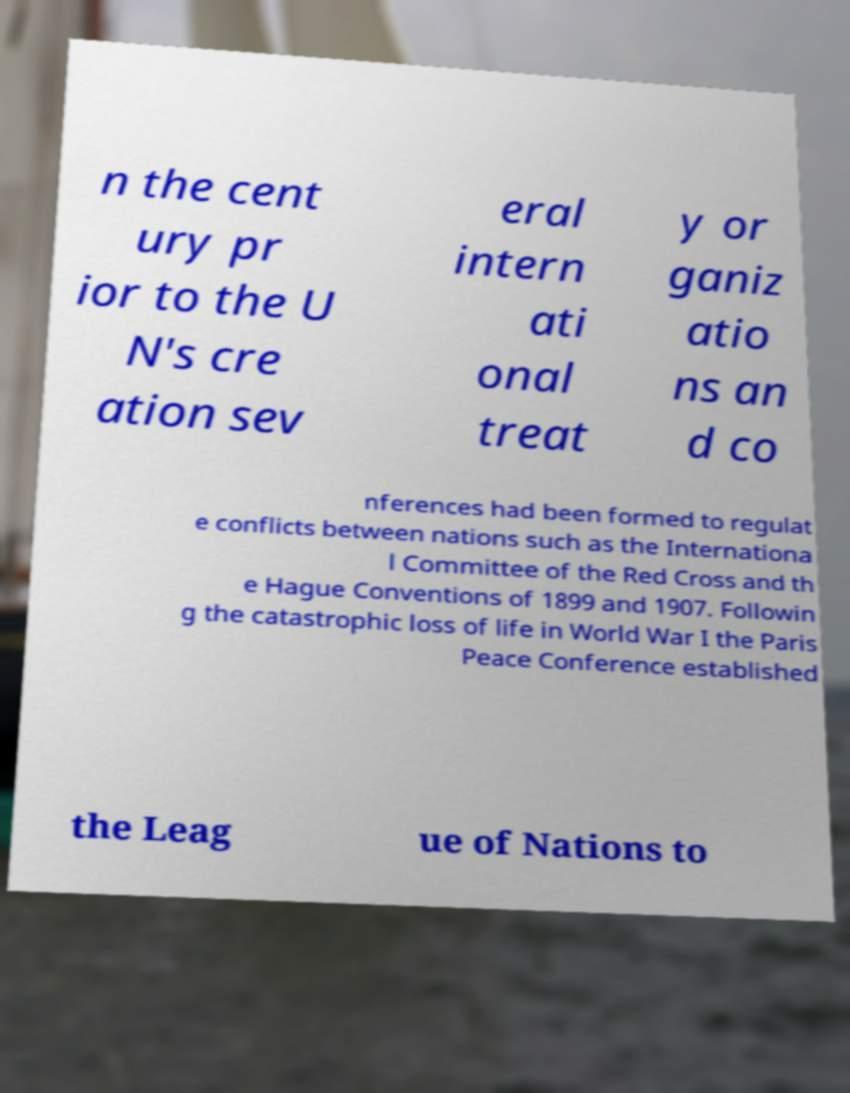Please identify and transcribe the text found in this image. n the cent ury pr ior to the U N's cre ation sev eral intern ati onal treat y or ganiz atio ns an d co nferences had been formed to regulat e conflicts between nations such as the Internationa l Committee of the Red Cross and th e Hague Conventions of 1899 and 1907. Followin g the catastrophic loss of life in World War I the Paris Peace Conference established the Leag ue of Nations to 